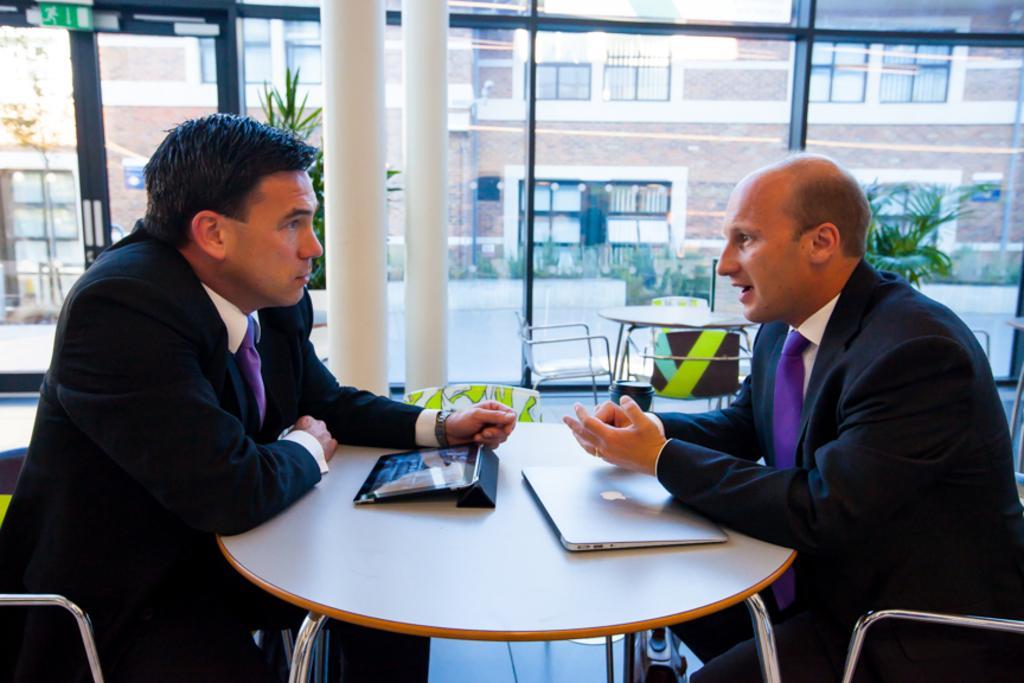Can you describe this image briefly? As we can see in the image, there are two persons sitting on chair. On table there is a tablet and laptop. In the background there is a road, red color building and few plants. 